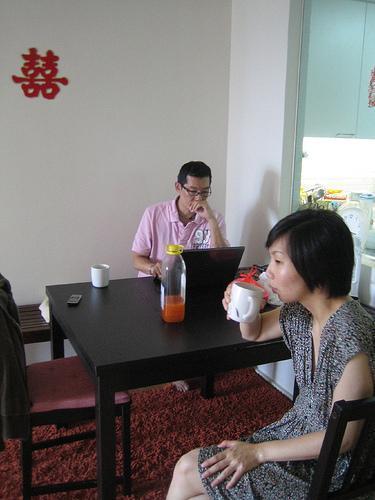How many cups are on the table?
Give a very brief answer. 1. How many people are there?
Give a very brief answer. 2. How many chairs are in the photo?
Give a very brief answer. 2. How many decors does the bus have?
Give a very brief answer. 0. 